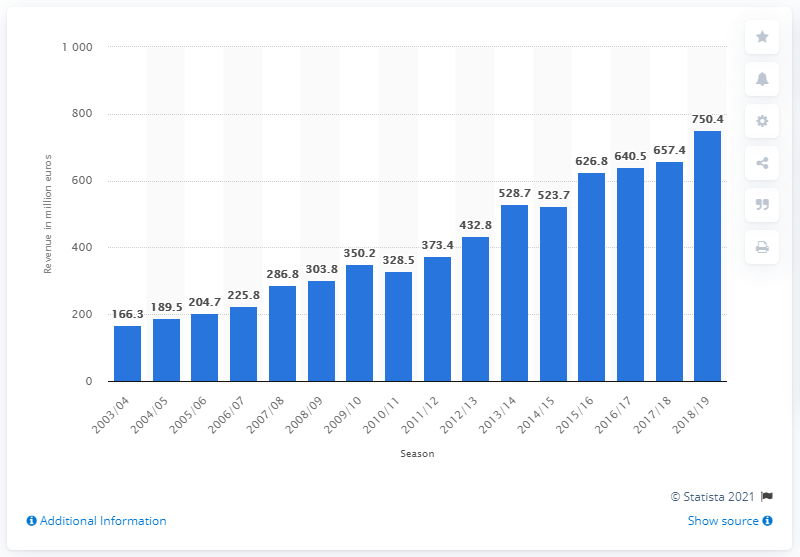List a handful of essential elements in this visual. In 2018, Bayern Munich's total revenue was 750.4 million. 